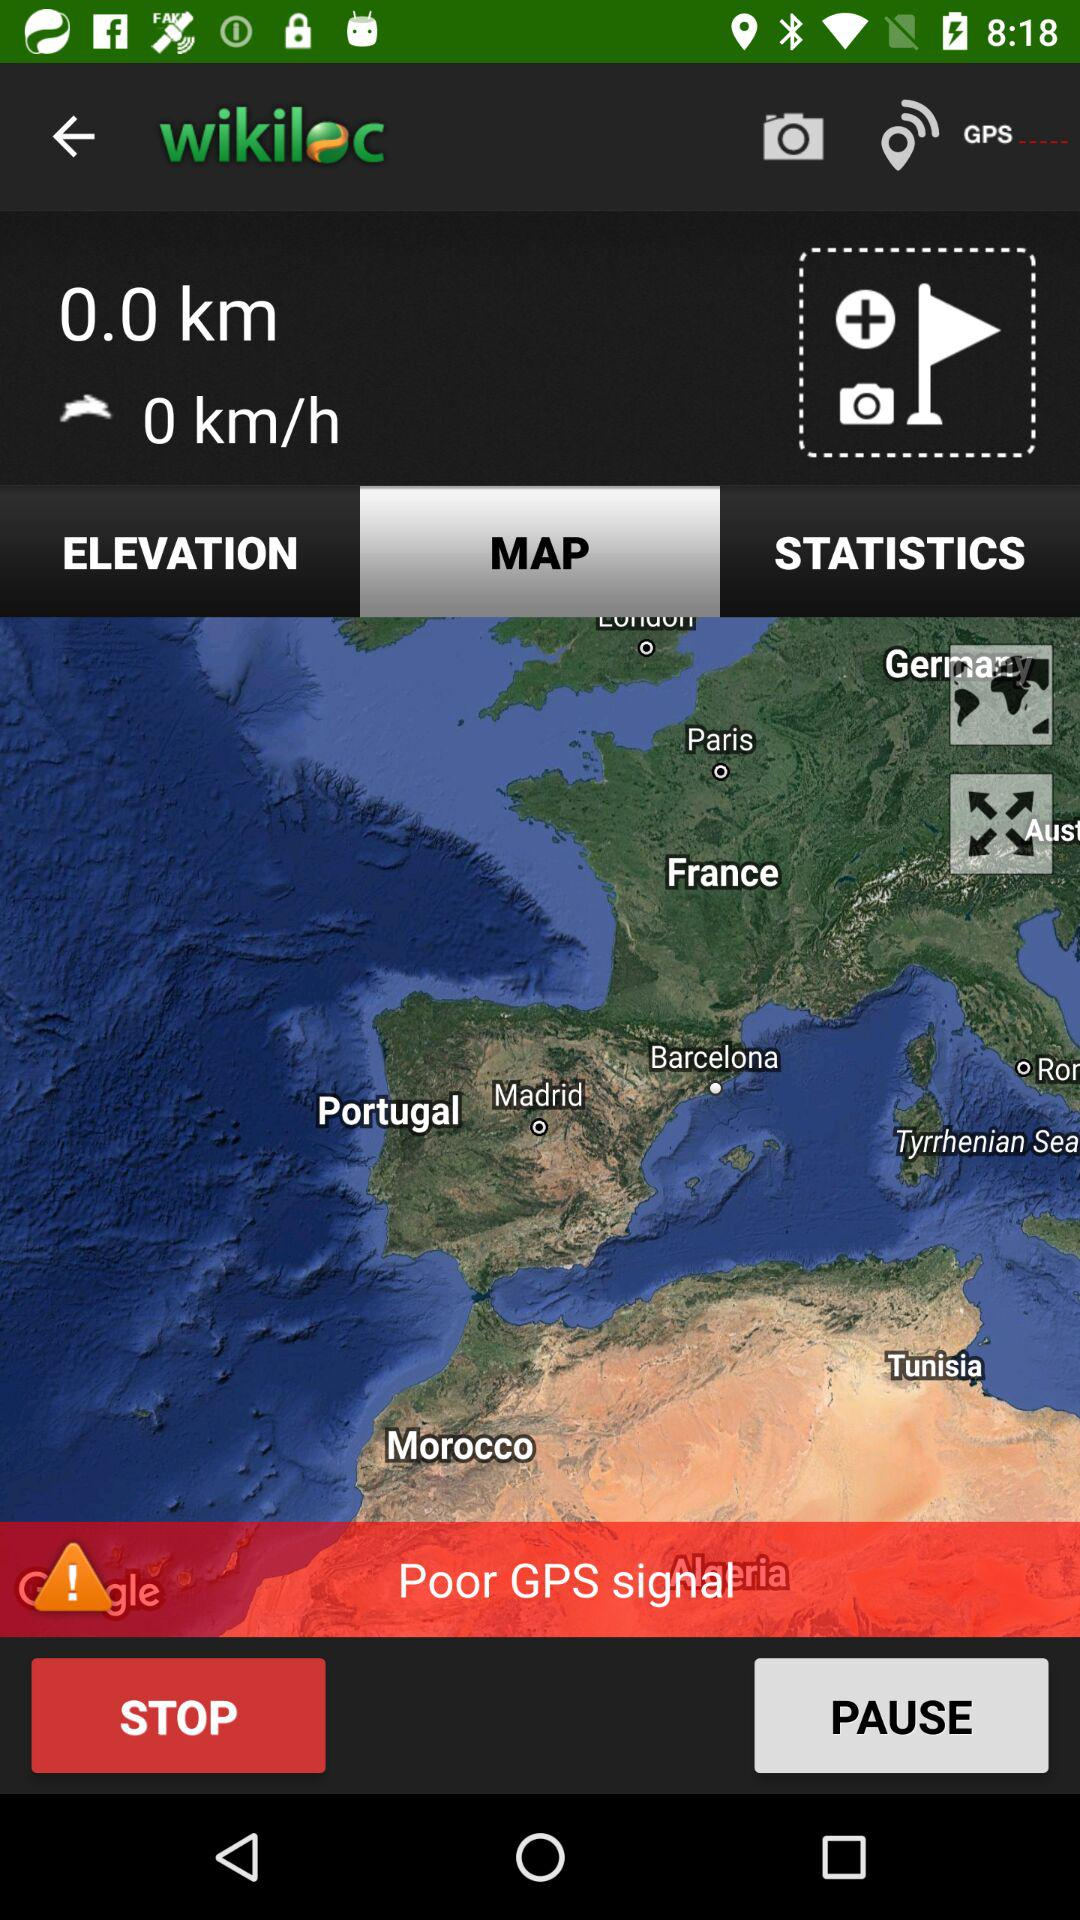How long is the path I've traveled?
Answer the question using a single word or phrase. 0.0 km 